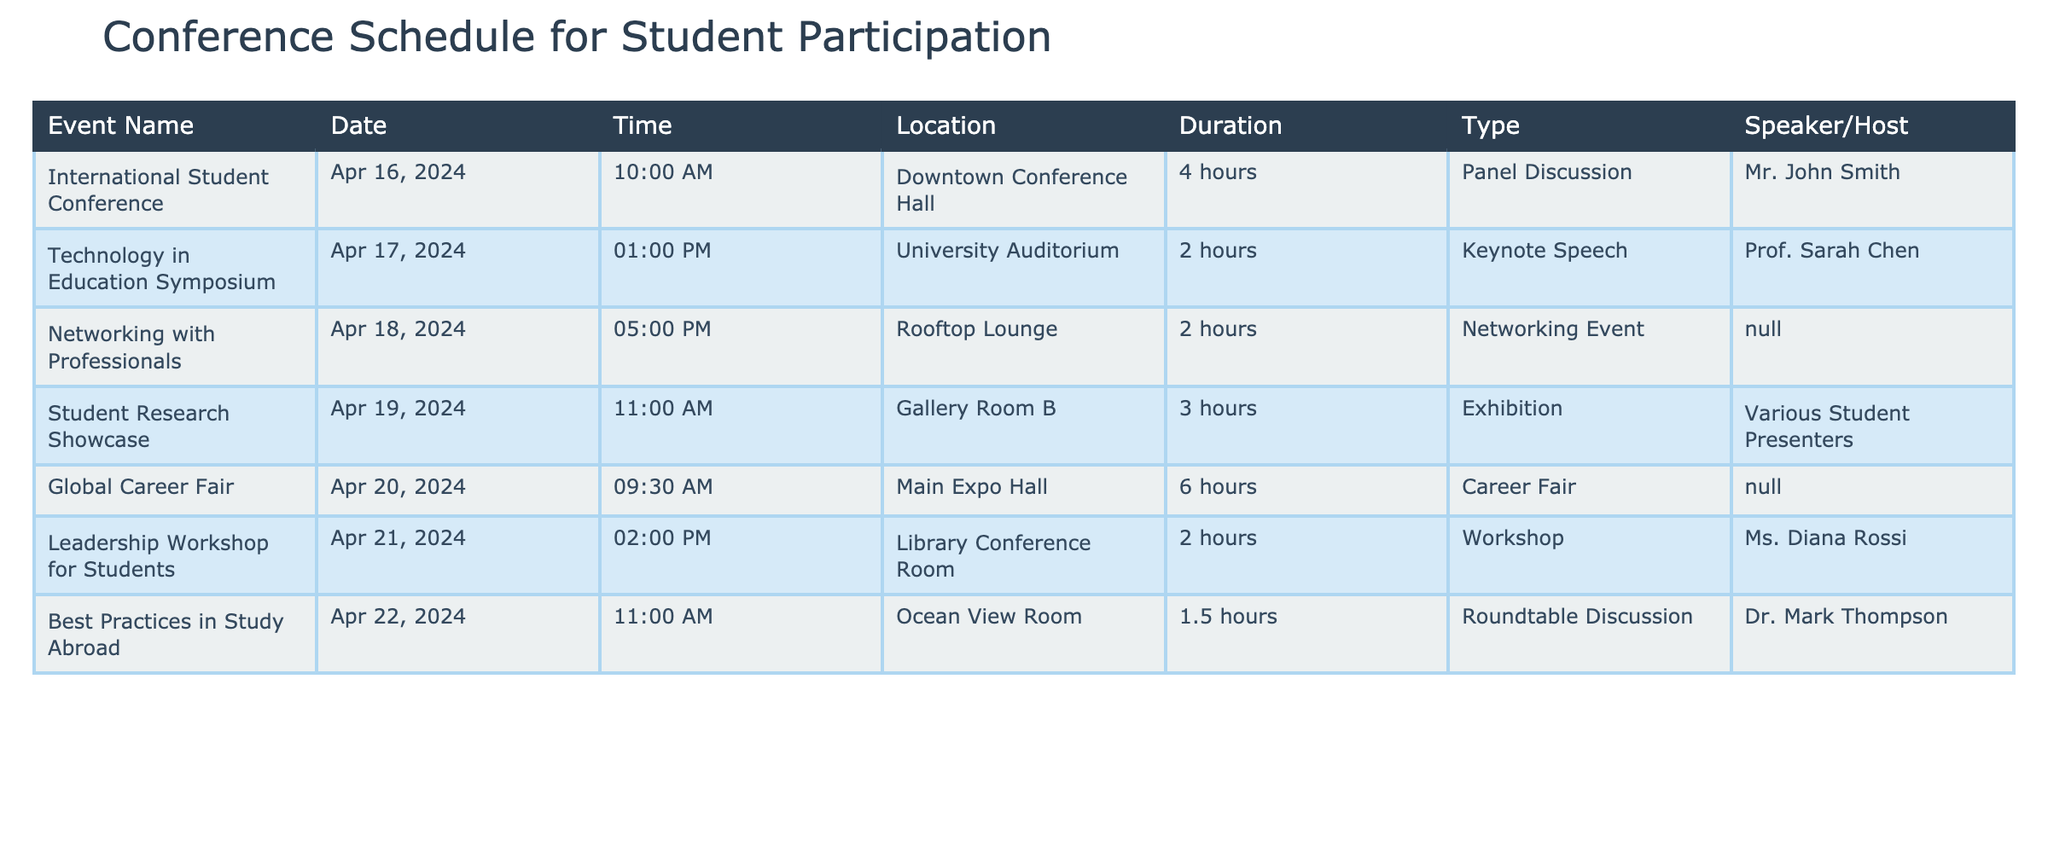What is the duration of the "Technology in Education Symposium"? The duration of this event is provided in the "Duration" column of the table. It states that the "Technology in Education Symposium" lasts for 2 hours.
Answer: 2 hours Who is the speaker for the "International Student Conference"? The "Speaker/Host" column indicates that the speaker for this event is Mr. John Smith.
Answer: Mr. John Smith On which date does the "Global Career Fair" take place? The "Date" column shows that the "Global Career Fair" is scheduled for April 20, 2024.
Answer: April 20, 2024 What is the combined duration of the "Best Practices in Study Abroad" and "Leadership Workshop for Students"? The duration of "Best Practices in Study Abroad" is 1.5 hours and "Leadership Workshop for Students" is 2 hours. Adding these gives 1.5 + 2 = 3.5 hours for both events combined.
Answer: 3.5 hours Is the "Networking with Professionals" event hosted by a specific individual? The "Speaker/Host" column indicates "N/A" for this event, which means it is not hosted by a specific individual.
Answer: No Which event has the longest duration and how long is it? By comparing the durations listed in the "Duration" column, "Global Career Fair" has the longest duration at 6 hours.
Answer: 6 hours If a student attends all events, how many total hours will they spend attending? To find this, sum all the durations: 4 + 2 + 2 + 3 + 6 + 2 + 1.5 = 20.5. Therefore, a student will spend a total of 20.5 hours attending all the events.
Answer: 20.5 hours What time does the "Student Research Showcase" start? The "Time" column shows that the "Student Research Showcase" starts at 11:00 AM.
Answer: 11:00 AM Which event is scheduled for the latest time on the agenda? Looking at the "Time" column, the latest event is "Global Career Fair," which starts at 09:30 AM.
Answer: 09:30 AM 